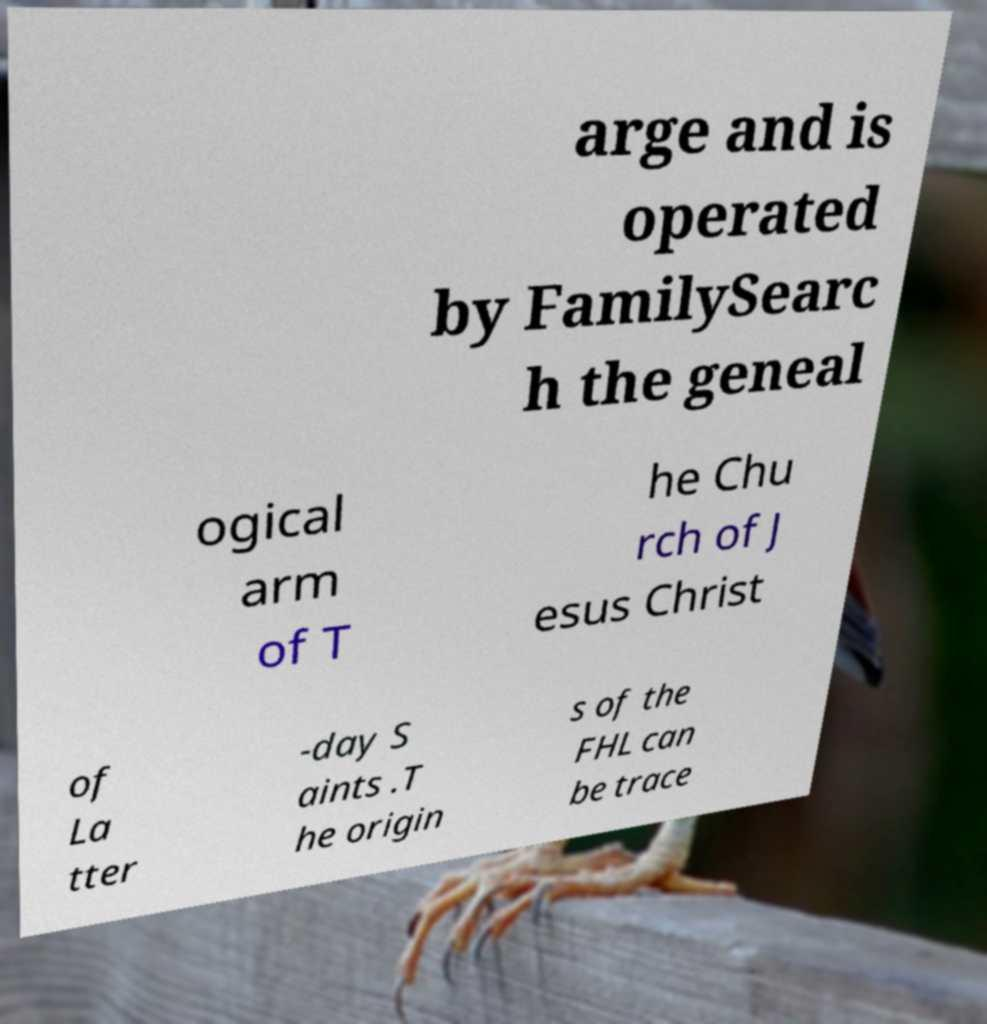Could you extract and type out the text from this image? arge and is operated by FamilySearc h the geneal ogical arm of T he Chu rch of J esus Christ of La tter -day S aints .T he origin s of the FHL can be trace 